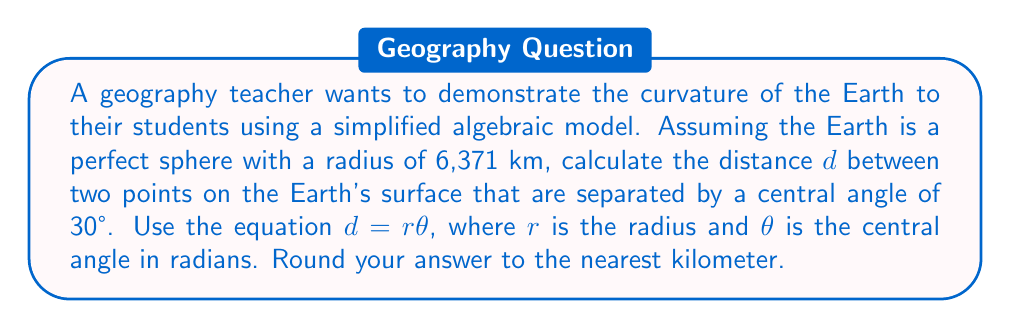Give your solution to this math problem. To solve this problem, we'll follow these steps:

1) First, we need to convert the central angle from degrees to radians. The formula for this conversion is:

   $\theta_{radians} = \theta_{degrees} \times \frac{\pi}{180°}$

   $\theta_{radians} = 30° \times \frac{\pi}{180°} = \frac{\pi}{6}$ radians

2) Now we have all the components to use in the equation $d = r\theta$:
   - $r = 6,371$ km (given radius of Earth)
   - $\theta = \frac{\pi}{6}$ radians (calculated in step 1)

3) Let's substitute these values into the equation:

   $d = 6,371 \times \frac{\pi}{6}$

4) Simplify:

   $d = 3,335.97...$ km

5) Rounding to the nearest kilometer:

   $d \approx 3,336$ km

This distance represents the length of the arc on the Earth's surface between the two points.
Answer: 3,336 km 